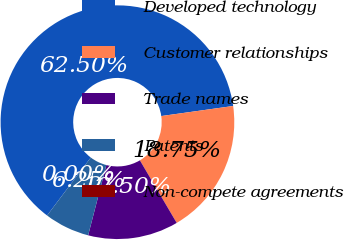Convert chart. <chart><loc_0><loc_0><loc_500><loc_500><pie_chart><fcel>Developed technology<fcel>Customer relationships<fcel>Trade names<fcel>Patents<fcel>Non-compete agreements<nl><fcel>62.5%<fcel>18.75%<fcel>12.5%<fcel>6.25%<fcel>0.0%<nl></chart> 